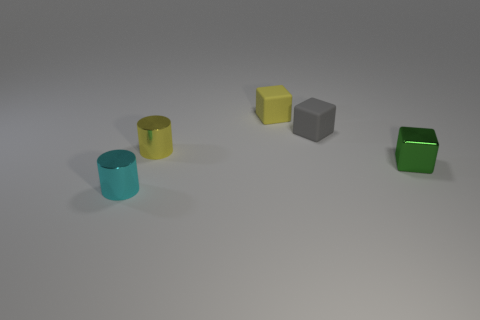Subtract all yellow blocks. Subtract all brown cylinders. How many blocks are left? 2 Add 2 blocks. How many objects exist? 7 Subtract all cubes. How many objects are left? 2 Add 2 small cubes. How many small cubes exist? 5 Subtract 1 yellow cylinders. How many objects are left? 4 Subtract all big cyan rubber objects. Subtract all green shiny blocks. How many objects are left? 4 Add 1 gray rubber things. How many gray rubber things are left? 2 